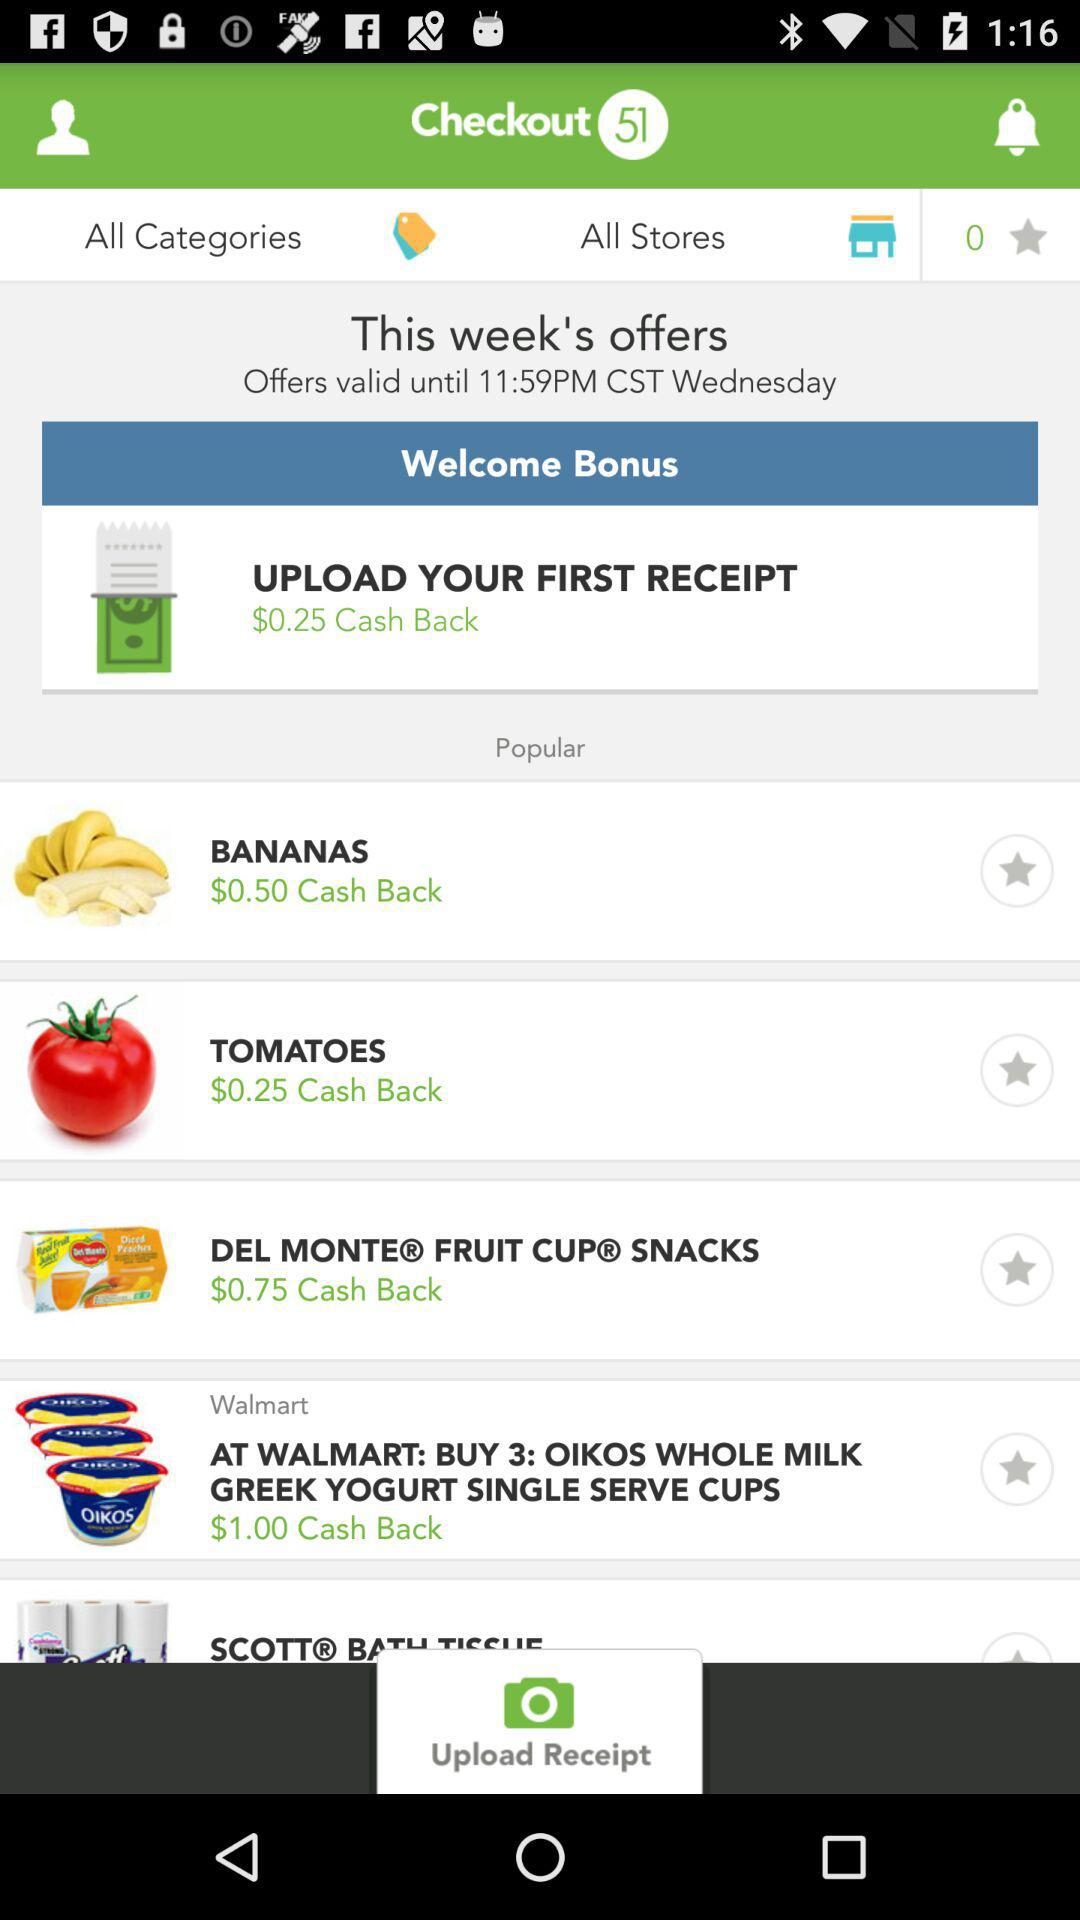Until what time is the offer valid? The offer is valid until 11:59 PM in Central Standard Time. 